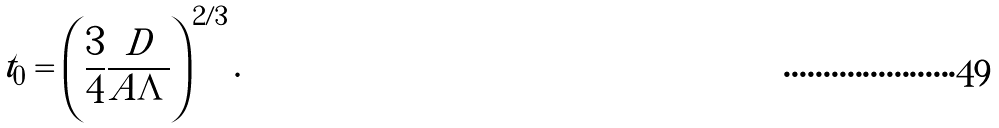Convert formula to latex. <formula><loc_0><loc_0><loc_500><loc_500>t _ { 0 } = \left ( \frac { 3 } { 4 } \frac { D } { A \Lambda } \right ) ^ { 2 / 3 } .</formula> 